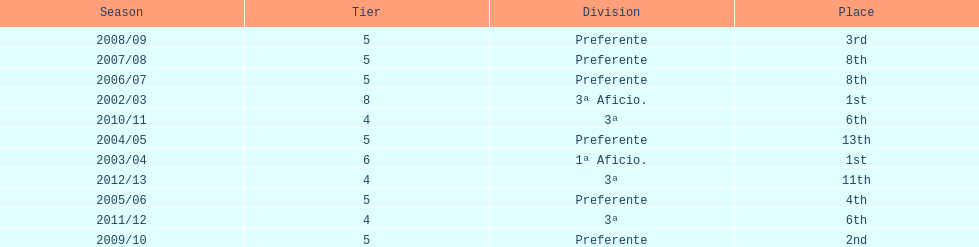How many times did internacional de madrid cf end the season at the top of their division? 2. 